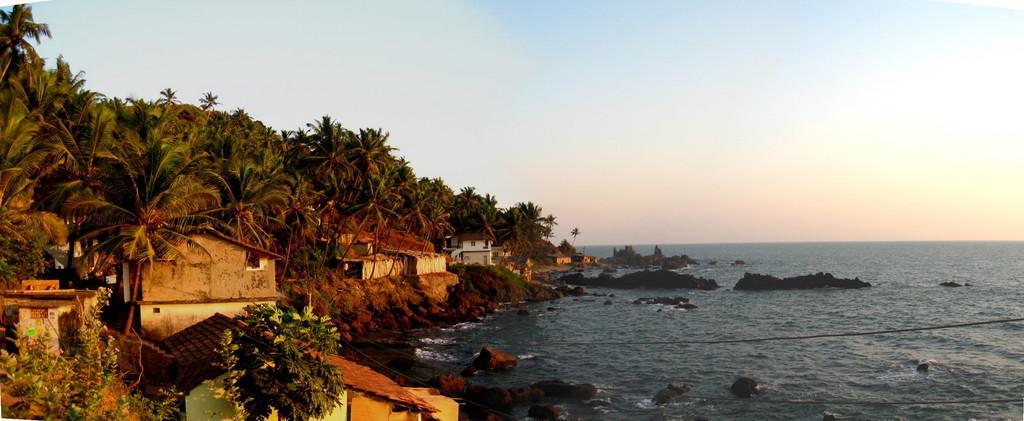Describe this image in one or two sentences. In this picture we can see few buildings, trees and water, and also we can see few rocks. 